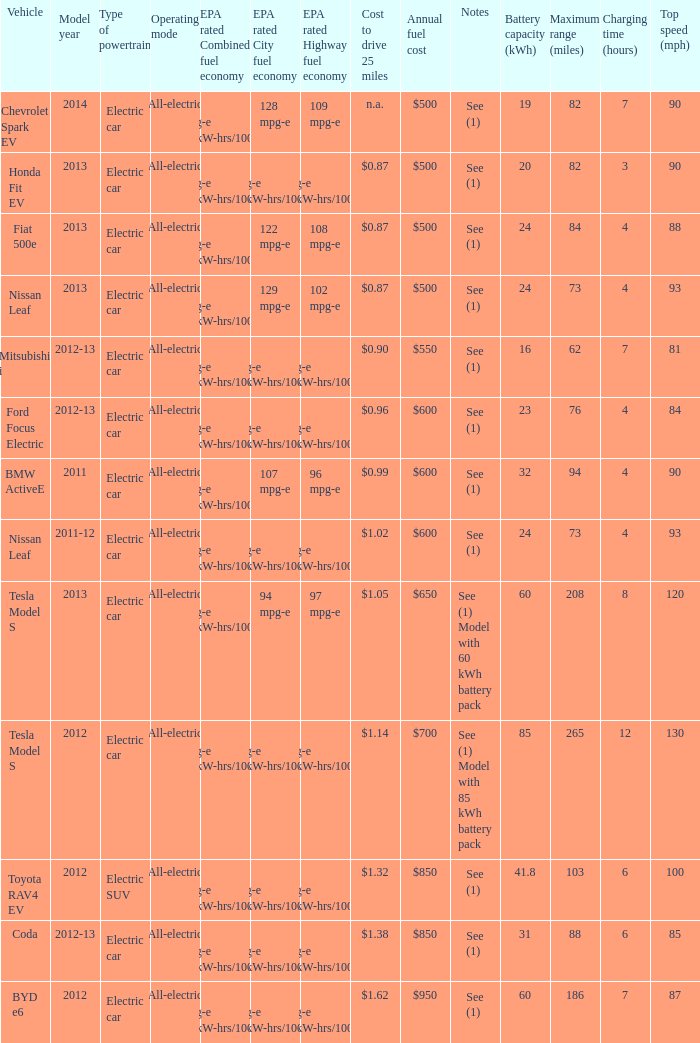What vehicle has an epa highway fuel economy of 109 mpg-e? Chevrolet Spark EV. 